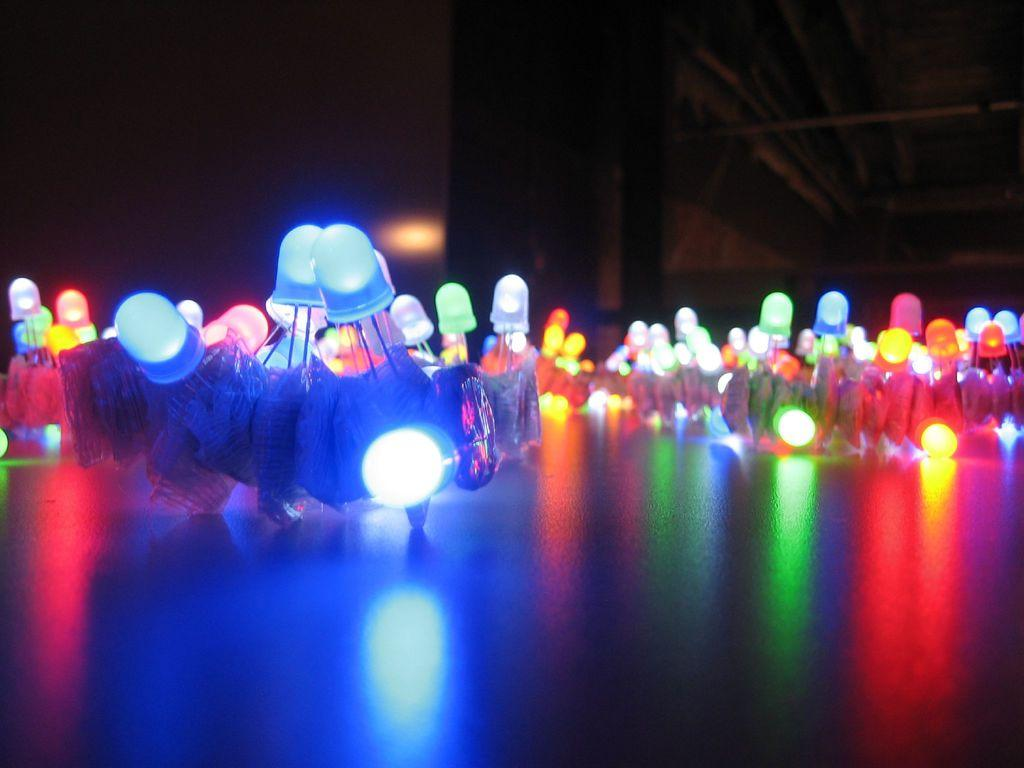What can be seen in the image that provides illumination? There are lights in the image. What is the color or tone of the background in the image? The background of the image is dark. Can you hear the whistle in the image? There is no whistle present in the image, so it cannot be heard. How many rings are visible on the person's fingers in the image? There is no person or rings visible in the image. Where is the lunchroom located in the image? There is no lunchroom present in the image. 